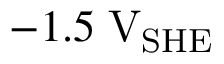<formula> <loc_0><loc_0><loc_500><loc_500>- 1 . 5 \, V _ { S H E }</formula> 